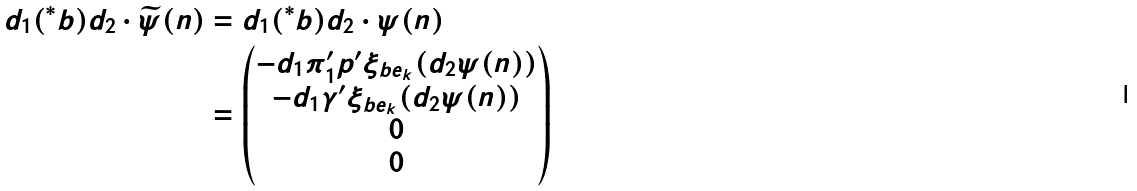Convert formula to latex. <formula><loc_0><loc_0><loc_500><loc_500>d _ { 1 } ( ^ { \ast } b ) d _ { 2 } \cdot \widetilde { \psi } ( n ) & = d _ { 1 } ( ^ { \ast } b ) d _ { 2 } \cdot \psi ( n ) \\ & = \begin{pmatrix} - d _ { 1 } \pi _ { 1 } ^ { \prime } p ^ { \prime } \xi _ { b e _ { k } } ( d _ { 2 } \psi ( n ) ) \\ - d _ { 1 } \gamma ^ { \prime } \xi _ { b e _ { k } } ( d _ { 2 } \psi ( n ) ) \\ 0 \\ 0 \end{pmatrix}</formula> 